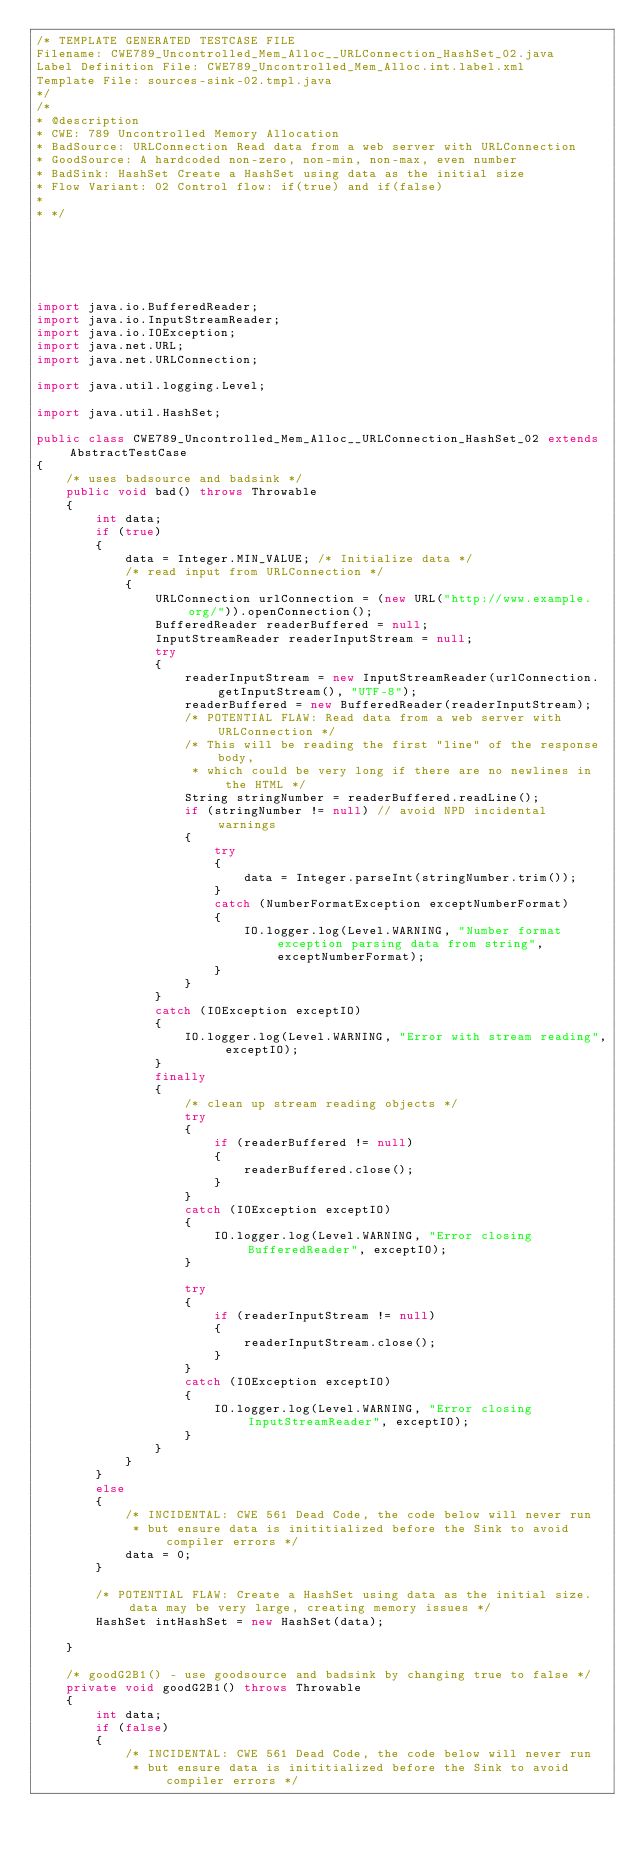<code> <loc_0><loc_0><loc_500><loc_500><_Java_>/* TEMPLATE GENERATED TESTCASE FILE
Filename: CWE789_Uncontrolled_Mem_Alloc__URLConnection_HashSet_02.java
Label Definition File: CWE789_Uncontrolled_Mem_Alloc.int.label.xml
Template File: sources-sink-02.tmpl.java
*/
/*
* @description
* CWE: 789 Uncontrolled Memory Allocation
* BadSource: URLConnection Read data from a web server with URLConnection
* GoodSource: A hardcoded non-zero, non-min, non-max, even number
* BadSink: HashSet Create a HashSet using data as the initial size
* Flow Variant: 02 Control flow: if(true) and if(false)
*
* */






import java.io.BufferedReader;
import java.io.InputStreamReader;
import java.io.IOException;
import java.net.URL;
import java.net.URLConnection;

import java.util.logging.Level;

import java.util.HashSet;

public class CWE789_Uncontrolled_Mem_Alloc__URLConnection_HashSet_02 extends AbstractTestCase
{
    /* uses badsource and badsink */
    public void bad() throws Throwable
    {
        int data;
        if (true)
        {
            data = Integer.MIN_VALUE; /* Initialize data */
            /* read input from URLConnection */
            {
                URLConnection urlConnection = (new URL("http://www.example.org/")).openConnection();
                BufferedReader readerBuffered = null;
                InputStreamReader readerInputStream = null;
                try
                {
                    readerInputStream = new InputStreamReader(urlConnection.getInputStream(), "UTF-8");
                    readerBuffered = new BufferedReader(readerInputStream);
                    /* POTENTIAL FLAW: Read data from a web server with URLConnection */
                    /* This will be reading the first "line" of the response body,
                     * which could be very long if there are no newlines in the HTML */
                    String stringNumber = readerBuffered.readLine();
                    if (stringNumber != null) // avoid NPD incidental warnings
                    {
                        try
                        {
                            data = Integer.parseInt(stringNumber.trim());
                        }
                        catch (NumberFormatException exceptNumberFormat)
                        {
                            IO.logger.log(Level.WARNING, "Number format exception parsing data from string", exceptNumberFormat);
                        }
                    }
                }
                catch (IOException exceptIO)
                {
                    IO.logger.log(Level.WARNING, "Error with stream reading", exceptIO);
                }
                finally
                {
                    /* clean up stream reading objects */
                    try
                    {
                        if (readerBuffered != null)
                        {
                            readerBuffered.close();
                        }
                    }
                    catch (IOException exceptIO)
                    {
                        IO.logger.log(Level.WARNING, "Error closing BufferedReader", exceptIO);
                    }

                    try
                    {
                        if (readerInputStream != null)
                        {
                            readerInputStream.close();
                        }
                    }
                    catch (IOException exceptIO)
                    {
                        IO.logger.log(Level.WARNING, "Error closing InputStreamReader", exceptIO);
                    }
                }
            }
        }
        else
        {
            /* INCIDENTAL: CWE 561 Dead Code, the code below will never run
             * but ensure data is inititialized before the Sink to avoid compiler errors */
            data = 0;
        }

        /* POTENTIAL FLAW: Create a HashSet using data as the initial size.  data may be very large, creating memory issues */
        HashSet intHashSet = new HashSet(data);

    }

    /* goodG2B1() - use goodsource and badsink by changing true to false */
    private void goodG2B1() throws Throwable
    {
        int data;
        if (false)
        {
            /* INCIDENTAL: CWE 561 Dead Code, the code below will never run
             * but ensure data is inititialized before the Sink to avoid compiler errors */</code> 